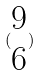Convert formula to latex. <formula><loc_0><loc_0><loc_500><loc_500>( \begin{matrix} 9 \\ 6 \end{matrix} )</formula> 